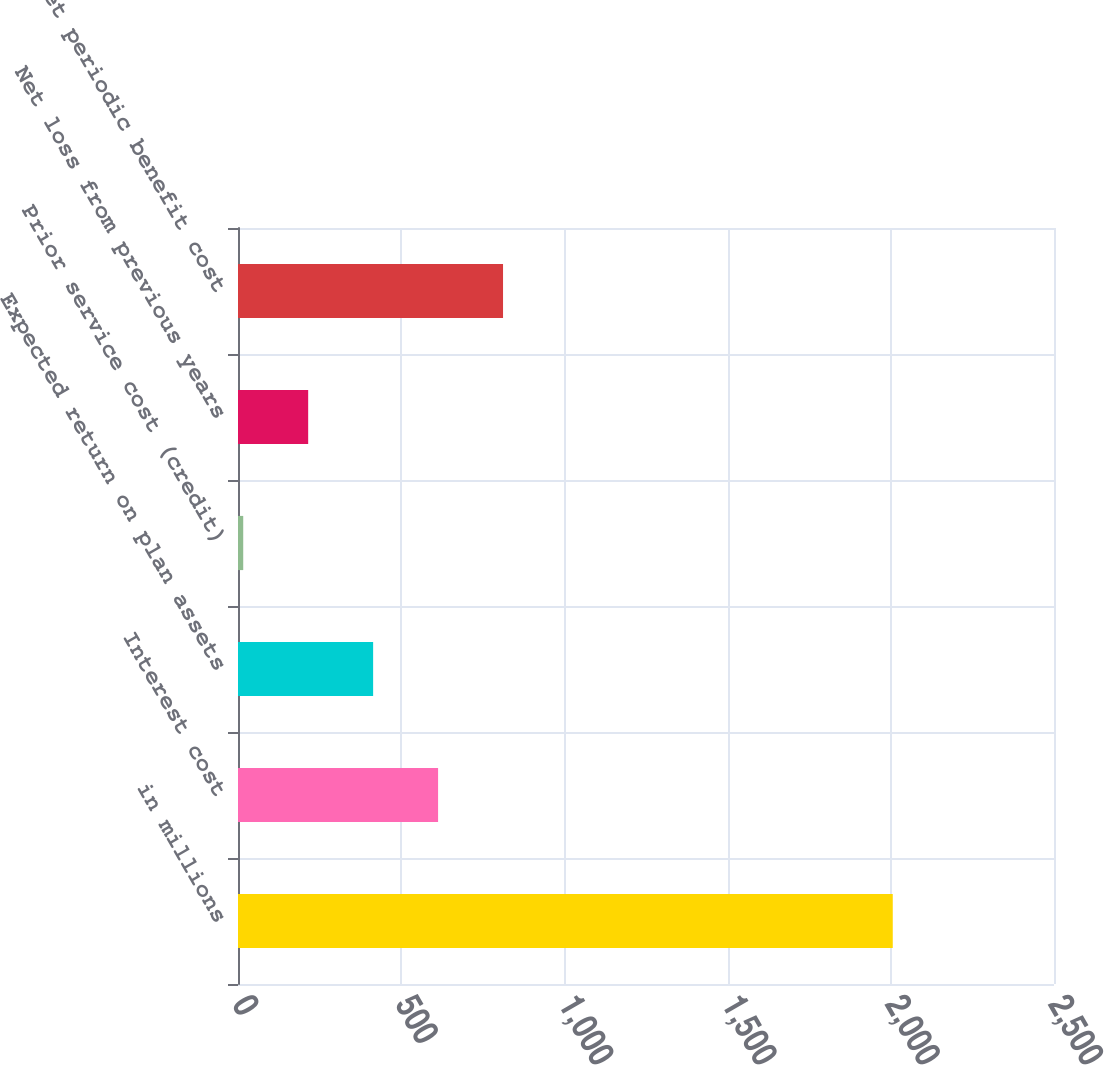Convert chart to OTSL. <chart><loc_0><loc_0><loc_500><loc_500><bar_chart><fcel>in millions<fcel>Interest cost<fcel>Expected return on plan assets<fcel>Prior service cost (credit)<fcel>Net loss from previous years<fcel>Net periodic benefit cost<nl><fcel>2006<fcel>613<fcel>414<fcel>16<fcel>215<fcel>812<nl></chart> 